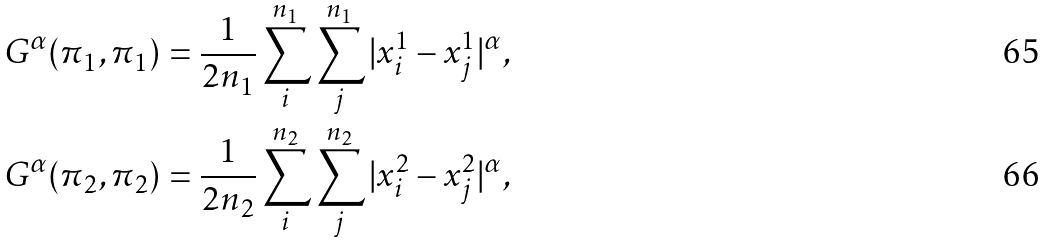Convert formula to latex. <formula><loc_0><loc_0><loc_500><loc_500>& G ^ { \alpha } ( \pi _ { 1 } , \pi _ { 1 } ) = \frac { 1 } { 2 n _ { 1 } } \sum _ { i } ^ { n _ { 1 } } \sum _ { j } ^ { n _ { 1 } } | x _ { i } ^ { 1 } - x _ { j } ^ { 1 } | ^ { \alpha } , \\ & G ^ { \alpha } ( \pi _ { 2 } , \pi _ { 2 } ) = \frac { 1 } { 2 n _ { 2 } } \sum _ { i } ^ { n _ { 2 } } \sum _ { j } ^ { n _ { 2 } } | x _ { i } ^ { 2 } - x _ { j } ^ { 2 } | ^ { \alpha } ,</formula> 